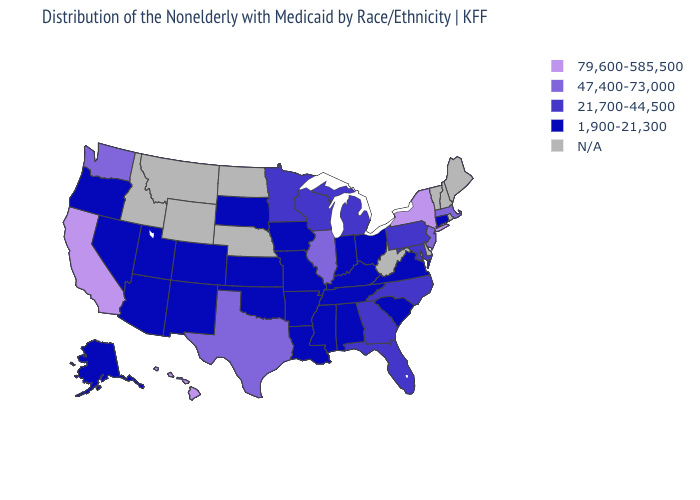Name the states that have a value in the range 47,400-73,000?
Concise answer only. Illinois, Massachusetts, New Jersey, Texas, Washington. Name the states that have a value in the range 79,600-585,500?
Quick response, please. California, Hawaii, New York. Among the states that border Vermont , does Massachusetts have the highest value?
Quick response, please. No. What is the highest value in the USA?
Quick response, please. 79,600-585,500. How many symbols are there in the legend?
Answer briefly. 5. Name the states that have a value in the range 79,600-585,500?
Quick response, please. California, Hawaii, New York. What is the value of Idaho?
Write a very short answer. N/A. Does the first symbol in the legend represent the smallest category?
Give a very brief answer. No. What is the value of Oklahoma?
Keep it brief. 1,900-21,300. Name the states that have a value in the range 47,400-73,000?
Keep it brief. Illinois, Massachusetts, New Jersey, Texas, Washington. Does Colorado have the lowest value in the West?
Quick response, please. Yes. Name the states that have a value in the range 79,600-585,500?
Write a very short answer. California, Hawaii, New York. What is the value of Colorado?
Quick response, please. 1,900-21,300. Name the states that have a value in the range N/A?
Quick response, please. Delaware, Idaho, Maine, Montana, Nebraska, New Hampshire, North Dakota, Rhode Island, Vermont, West Virginia, Wyoming. 